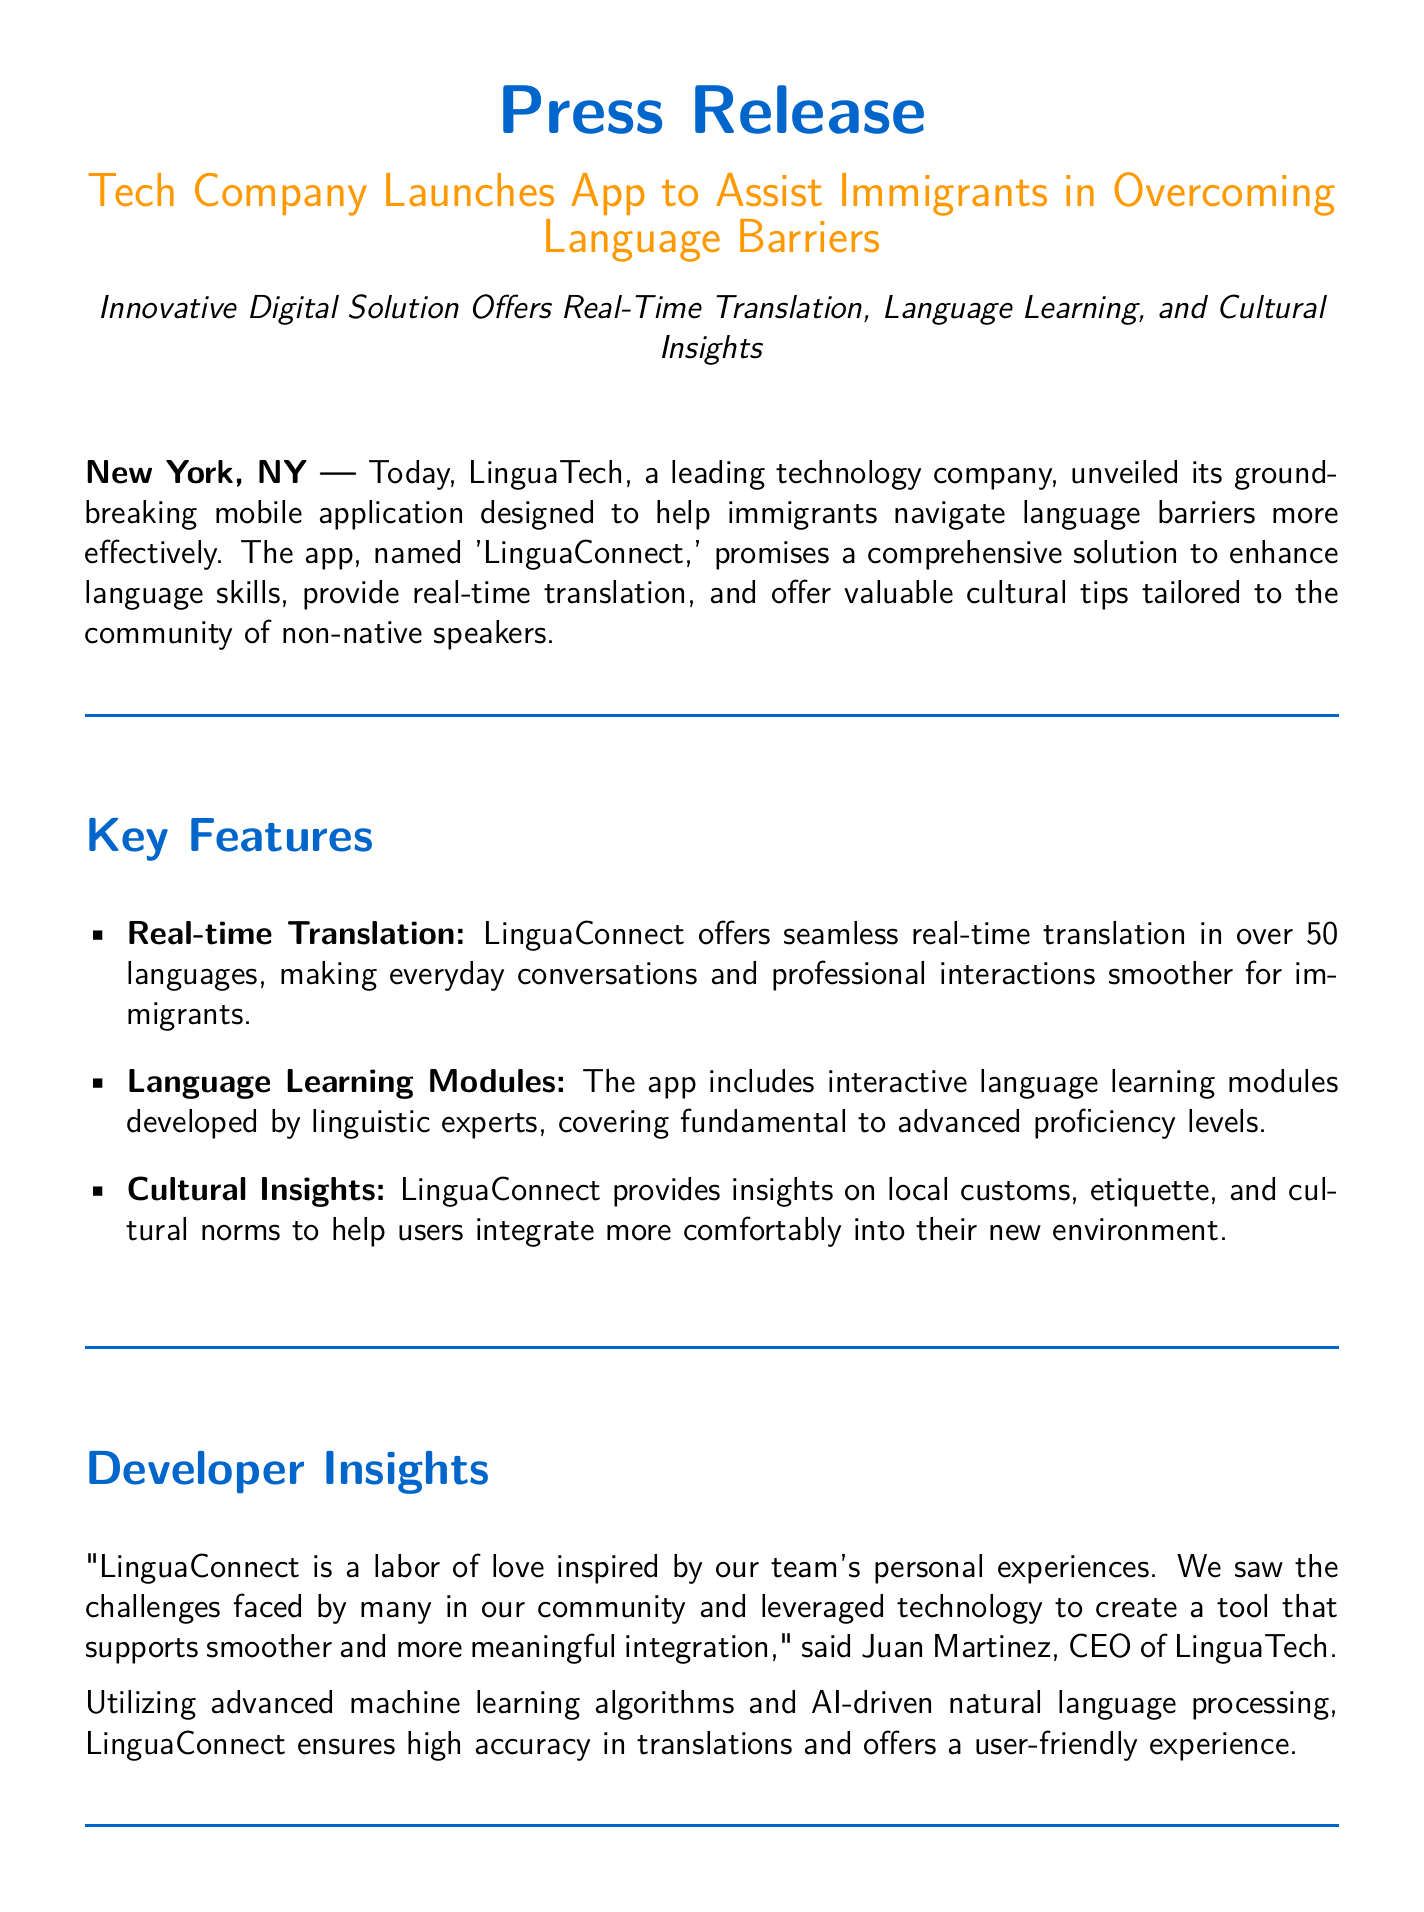What is the name of the app launched? The name of the app launched by LinguaTech is 'LinguaConnect.'
Answer: 'LinguaConnect' How many languages does the app support for real-time translation? LinguaConnect offers real-time translation in over 50 languages.
Answer: over 50 languages Who is the CEO of LinguaTech? The CEO of LinguaTech is Juan Martinez.
Answer: Juan Martinez What percentage faster can immigrants improve their language skills using LinguaConnect compared to traditional methods? Research suggests that immigrants can improve their language skills 40% faster using tools like LinguaConnect.
Answer: 40% What is the main focus of LinguaConnect? The main focus of LinguaConnect is to assist immigrants in overcoming language barriers.
Answer: overcoming language barriers What type of insights does the app provide? The app provides cultural insights on local customs, etiquette, and cultural norms.
Answer: cultural insights What milestone did LinguaConnect achieve within the first month of its beta launch? LinguaConnect attracted over 100,000 users worldwide within the first month of its beta launch.
Answer: over 100,000 users How does the CEO describe the creation of LinguaConnect? Juan Martinez describes the creation of LinguaConnect as a labor of love inspired by the team's personal experiences.
Answer: a labor of love What is the media contact's email address? The media contact's email address is press@linguatech.com.
Answer: press@linguatech.com 